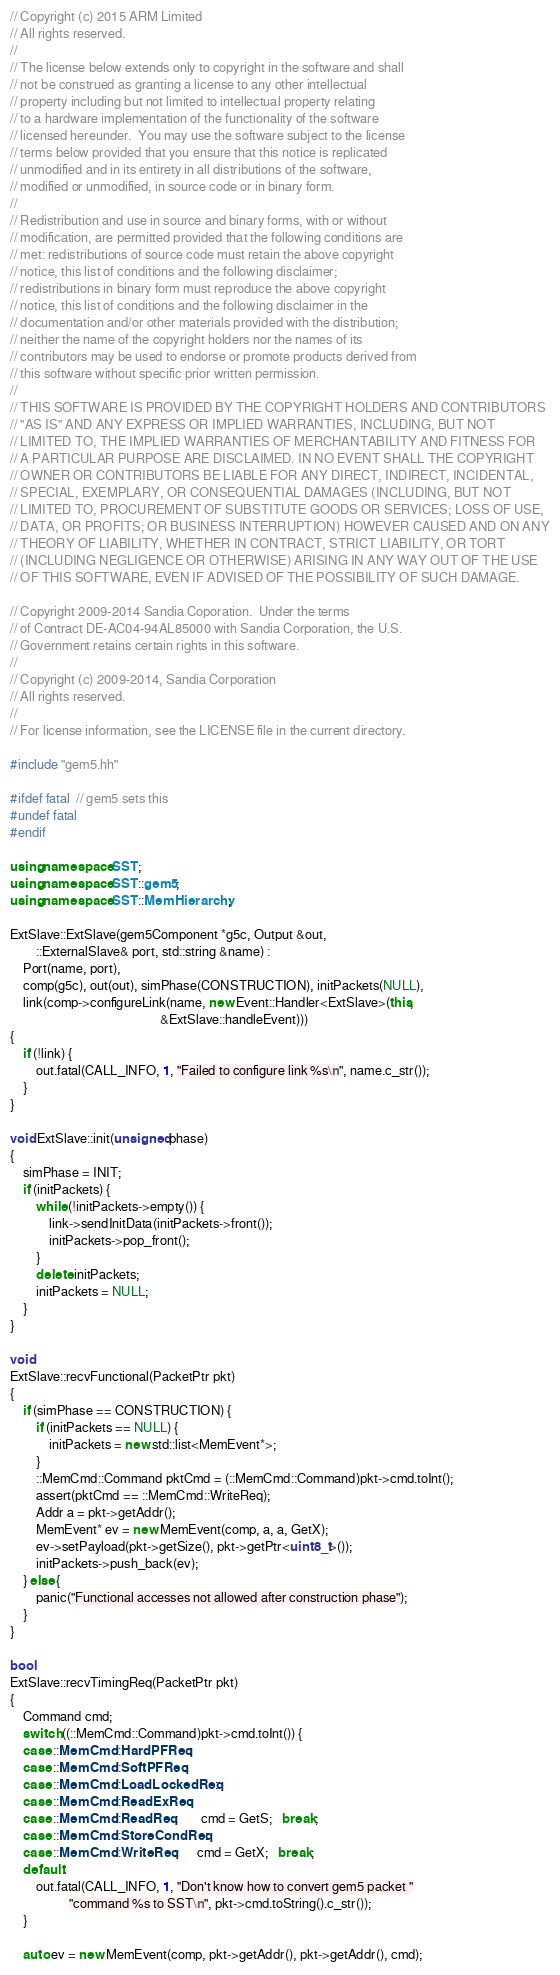<code> <loc_0><loc_0><loc_500><loc_500><_C++_>// Copyright (c) 2015 ARM Limited
// All rights reserved.
//
// The license below extends only to copyright in the software and shall
// not be construed as granting a license to any other intellectual
// property including but not limited to intellectual property relating
// to a hardware implementation of the functionality of the software
// licensed hereunder.  You may use the software subject to the license
// terms below provided that you ensure that this notice is replicated
// unmodified and in its entirety in all distributions of the software,
// modified or unmodified, in source code or in binary form.
//
// Redistribution and use in source and binary forms, with or without
// modification, are permitted provided that the following conditions are
// met: redistributions of source code must retain the above copyright
// notice, this list of conditions and the following disclaimer;
// redistributions in binary form must reproduce the above copyright
// notice, this list of conditions and the following disclaimer in the
// documentation and/or other materials provided with the distribution;
// neither the name of the copyright holders nor the names of its
// contributors may be used to endorse or promote products derived from
// this software without specific prior written permission.
//
// THIS SOFTWARE IS PROVIDED BY THE COPYRIGHT HOLDERS AND CONTRIBUTORS
// "AS IS" AND ANY EXPRESS OR IMPLIED WARRANTIES, INCLUDING, BUT NOT
// LIMITED TO, THE IMPLIED WARRANTIES OF MERCHANTABILITY AND FITNESS FOR
// A PARTICULAR PURPOSE ARE DISCLAIMED. IN NO EVENT SHALL THE COPYRIGHT
// OWNER OR CONTRIBUTORS BE LIABLE FOR ANY DIRECT, INDIRECT, INCIDENTAL,
// SPECIAL, EXEMPLARY, OR CONSEQUENTIAL DAMAGES (INCLUDING, BUT NOT
// LIMITED TO, PROCUREMENT OF SUBSTITUTE GOODS OR SERVICES; LOSS OF USE,
// DATA, OR PROFITS; OR BUSINESS INTERRUPTION) HOWEVER CAUSED AND ON ANY
// THEORY OF LIABILITY, WHETHER IN CONTRACT, STRICT LIABILITY, OR TORT
// (INCLUDING NEGLIGENCE OR OTHERWISE) ARISING IN ANY WAY OUT OF THE USE
// OF THIS SOFTWARE, EVEN IF ADVISED OF THE POSSIBILITY OF SUCH DAMAGE.

// Copyright 2009-2014 Sandia Coporation.  Under the terms
// of Contract DE-AC04-94AL85000 with Sandia Corporation, the U.S.
// Government retains certain rights in this software.
//
// Copyright (c) 2009-2014, Sandia Corporation
// All rights reserved.
//
// For license information, see the LICENSE file in the current directory.

#include "gem5.hh"

#ifdef fatal  // gem5 sets this
#undef fatal
#endif

using namespace SST;
using namespace SST::gem5;
using namespace SST::MemHierarchy;

ExtSlave::ExtSlave(gem5Component *g5c, Output &out,
        ::ExternalSlave& port, std::string &name) :
    Port(name, port),
    comp(g5c), out(out), simPhase(CONSTRUCTION), initPackets(NULL),
    link(comp->configureLink(name, new Event::Handler<ExtSlave>(this,
                                              &ExtSlave::handleEvent)))
{
    if (!link) {
        out.fatal(CALL_INFO, 1, "Failed to configure link %s\n", name.c_str());
    }
}

void ExtSlave::init(unsigned phase)
{
    simPhase = INIT;
    if (initPackets) {
        while (!initPackets->empty()) {
            link->sendInitData(initPackets->front());
            initPackets->pop_front();
        }
        delete initPackets;
        initPackets = NULL;
    }
}

void
ExtSlave::recvFunctional(PacketPtr pkt)
{
    if (simPhase == CONSTRUCTION) {
        if (initPackets == NULL) {
            initPackets = new std::list<MemEvent*>;
        }
        ::MemCmd::Command pktCmd = (::MemCmd::Command)pkt->cmd.toInt();
        assert(pktCmd == ::MemCmd::WriteReq);
        Addr a = pkt->getAddr();
        MemEvent* ev = new MemEvent(comp, a, a, GetX);
        ev->setPayload(pkt->getSize(), pkt->getPtr<uint8_t>());
        initPackets->push_back(ev);
    } else {
        panic("Functional accesses not allowed after construction phase");
    }
}

bool
ExtSlave::recvTimingReq(PacketPtr pkt)
{
    Command cmd;
    switch ((::MemCmd::Command)pkt->cmd.toInt()) {
    case ::MemCmd::HardPFReq:
    case ::MemCmd::SoftPFReq:
    case ::MemCmd::LoadLockedReq:
    case ::MemCmd::ReadExReq:
    case ::MemCmd::ReadReq:       cmd = GetS;   break;
    case ::MemCmd::StoreCondReq:
    case ::MemCmd::WriteReq:      cmd = GetX;   break;
    default:
        out.fatal(CALL_INFO, 1, "Don't know how to convert gem5 packet "
                  "command %s to SST\n", pkt->cmd.toString().c_str());
    }

    auto ev = new MemEvent(comp, pkt->getAddr(), pkt->getAddr(), cmd);</code> 